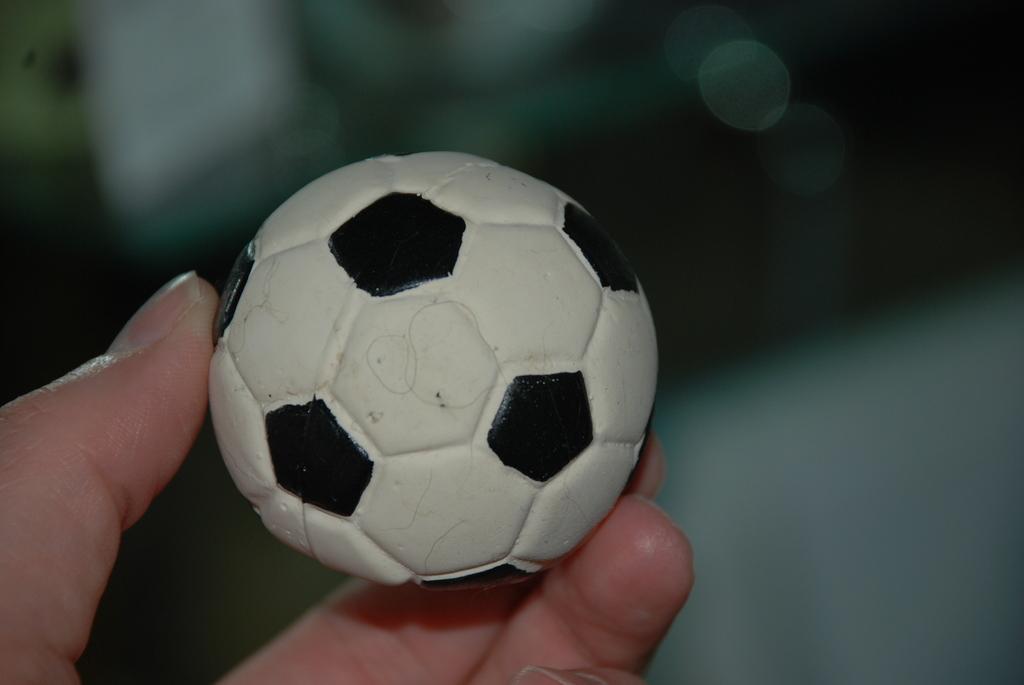Could you give a brief overview of what you see in this image? In this image I can see a human hand holding a small ball which is white and black in color. 